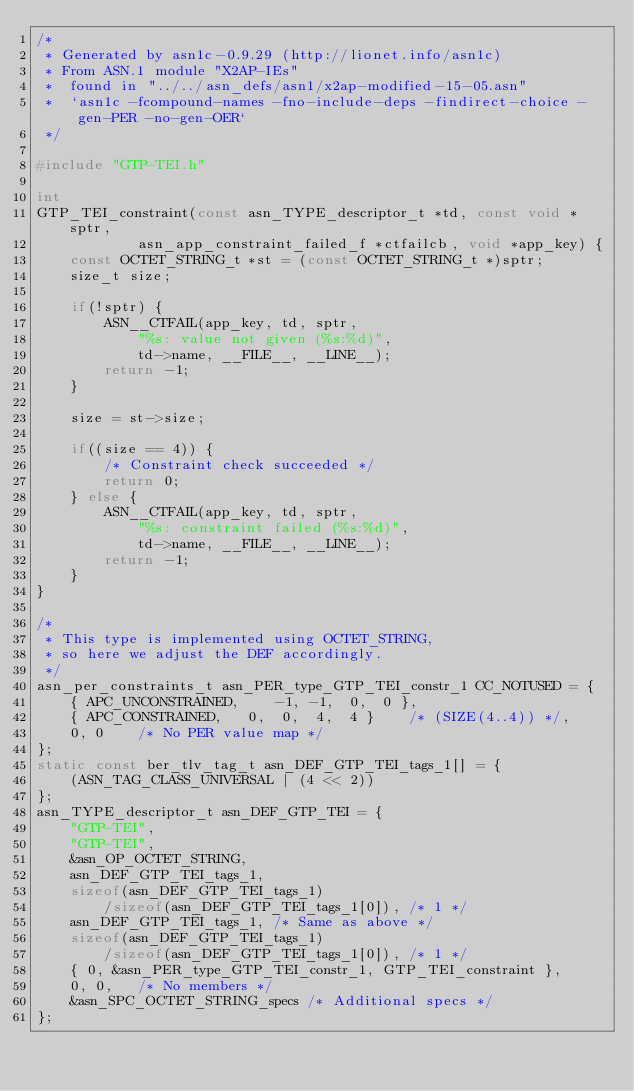Convert code to text. <code><loc_0><loc_0><loc_500><loc_500><_C_>/*
 * Generated by asn1c-0.9.29 (http://lionet.info/asn1c)
 * From ASN.1 module "X2AP-IEs"
 * 	found in "../../asn_defs/asn1/x2ap-modified-15-05.asn"
 * 	`asn1c -fcompound-names -fno-include-deps -findirect-choice -gen-PER -no-gen-OER`
 */

#include "GTP-TEI.h"

int
GTP_TEI_constraint(const asn_TYPE_descriptor_t *td, const void *sptr,
			asn_app_constraint_failed_f *ctfailcb, void *app_key) {
	const OCTET_STRING_t *st = (const OCTET_STRING_t *)sptr;
	size_t size;
	
	if(!sptr) {
		ASN__CTFAIL(app_key, td, sptr,
			"%s: value not given (%s:%d)",
			td->name, __FILE__, __LINE__);
		return -1;
	}
	
	size = st->size;
	
	if((size == 4)) {
		/* Constraint check succeeded */
		return 0;
	} else {
		ASN__CTFAIL(app_key, td, sptr,
			"%s: constraint failed (%s:%d)",
			td->name, __FILE__, __LINE__);
		return -1;
	}
}

/*
 * This type is implemented using OCTET_STRING,
 * so here we adjust the DEF accordingly.
 */
asn_per_constraints_t asn_PER_type_GTP_TEI_constr_1 CC_NOTUSED = {
	{ APC_UNCONSTRAINED,	-1, -1,  0,  0 },
	{ APC_CONSTRAINED,	 0,  0,  4,  4 }	/* (SIZE(4..4)) */,
	0, 0	/* No PER value map */
};
static const ber_tlv_tag_t asn_DEF_GTP_TEI_tags_1[] = {
	(ASN_TAG_CLASS_UNIVERSAL | (4 << 2))
};
asn_TYPE_descriptor_t asn_DEF_GTP_TEI = {
	"GTP-TEI",
	"GTP-TEI",
	&asn_OP_OCTET_STRING,
	asn_DEF_GTP_TEI_tags_1,
	sizeof(asn_DEF_GTP_TEI_tags_1)
		/sizeof(asn_DEF_GTP_TEI_tags_1[0]), /* 1 */
	asn_DEF_GTP_TEI_tags_1,	/* Same as above */
	sizeof(asn_DEF_GTP_TEI_tags_1)
		/sizeof(asn_DEF_GTP_TEI_tags_1[0]), /* 1 */
	{ 0, &asn_PER_type_GTP_TEI_constr_1, GTP_TEI_constraint },
	0, 0,	/* No members */
	&asn_SPC_OCTET_STRING_specs	/* Additional specs */
};

</code> 